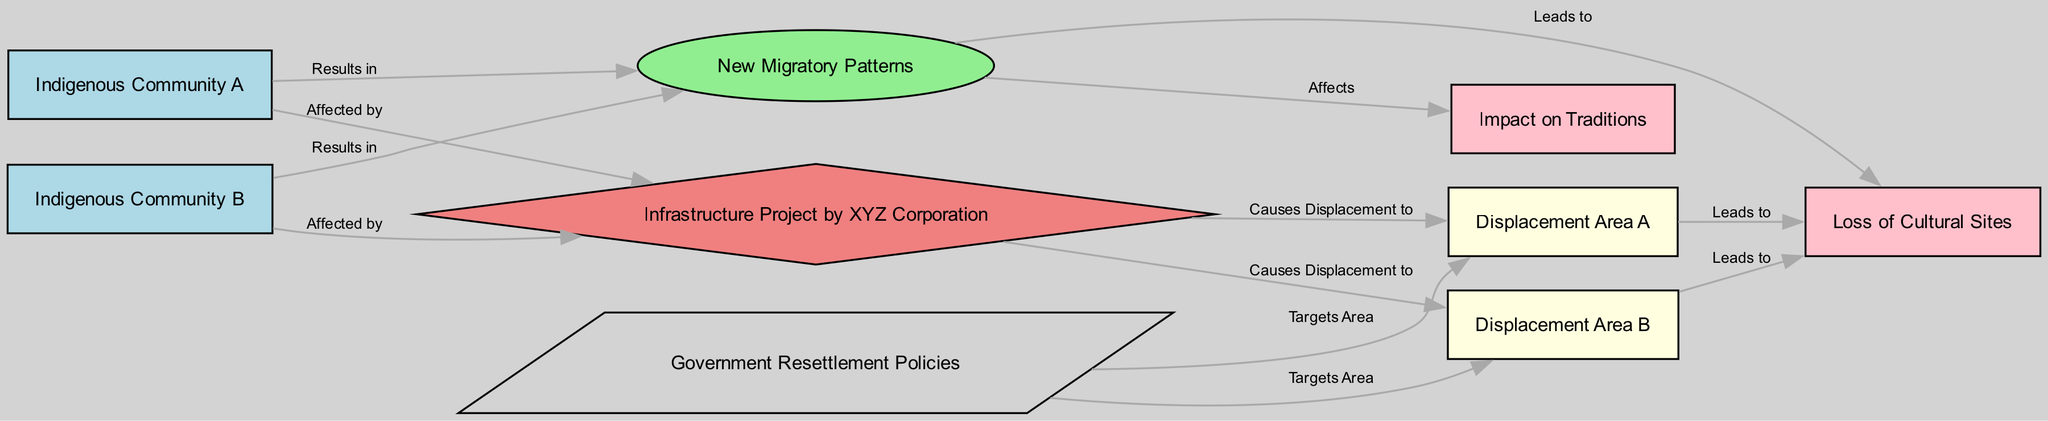What is the total number of nodes in the diagram? The diagram contains 9 nodes, which are the distinct entities labeled as Indigenous Community A, Indigenous Community B, Infrastructure Project by XYZ Corporation, Displacement Area A, Displacement Area B, New Migratory Patterns, Loss of Cultural Sites, Impact on Traditions, and Government Resettlement Policies.
Answer: 9 What does the label on the edge from Indigenous Community A to the Infrastructure Project by XYZ Corporation indicate? The label on the edge indicates that Indigenous Community A is "Affected by" the Infrastructure Project by XYZ Corporation, showing the relationship of influence or impact one entity has on the other.
Answer: Affected by Which Indigenous community is affected by the Infrastructure Project by XYZ Corporation? Both Indigenous Community A and Indigenous Community B are affected by the Infrastructure Project by XYZ Corporation, as indicated by two separate edges that connect each community to the project.
Answer: Indigenous Community A and Indigenous Community B Where does the Infrastructure Project by XYZ Corporation cause displacement? The Infrastructure Project by XYZ Corporation causes displacement to Displacement Area A and Displacement Area B, as shown by the edges leading from the project to these displacement areas.
Answer: Displacement Area A and Displacement Area B What is the result of the new migratory patterns for both Indigenous communities? The new migratory patterns lead to the loss of cultural sites and affect traditions, demonstrating the societal impacts of displacement on the indigenous identity and practices.
Answer: Loss of Cultural Sites and Impact on Traditions What are the two consequences of displacement areas A and B? Both Displacement Area A and Displacement Area B lead to the loss of cultural sites, signifying the common outcome of displacement for the indigenous communities occurring in these areas.
Answer: Loss of Cultural Sites Which policies target the displacement areas? The Government Resettlement Policies target both Displacement Area A and Displacement Area B, indicating a governmental response to the needs or situations created due to the displacement.
Answer: Displacement Area A and Displacement Area B What type of diagram is represented here and what does its structure suggest? This is a Social Science Diagram, which visually represents the relationships between different entities and helps in understanding the socio-economic and cultural implications of a specific phenomenon, in this case, disruption caused by a business project.
Answer: Social Science Diagram 